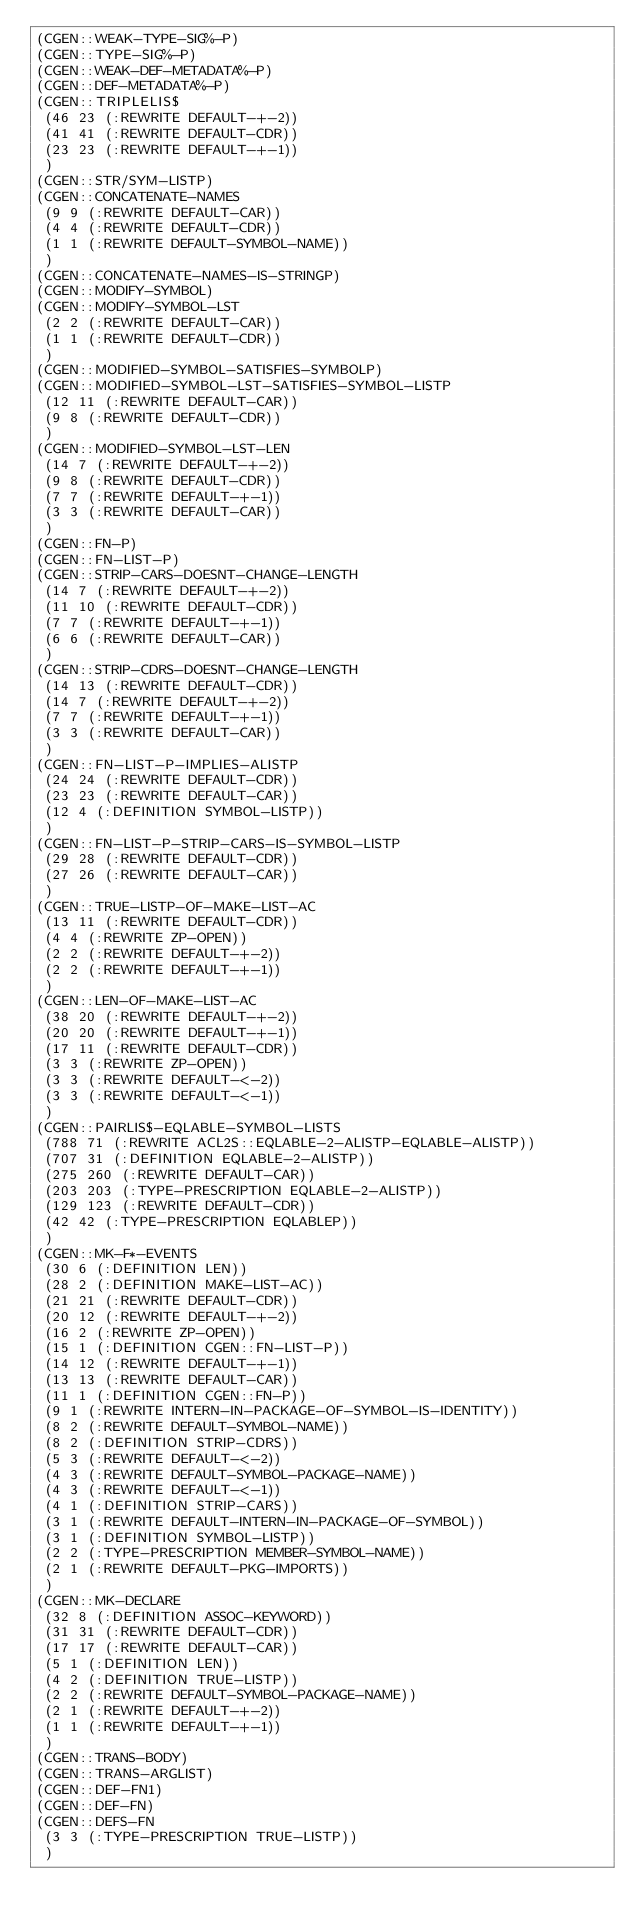Convert code to text. <code><loc_0><loc_0><loc_500><loc_500><_Lisp_>(CGEN::WEAK-TYPE-SIG%-P)
(CGEN::TYPE-SIG%-P)
(CGEN::WEAK-DEF-METADATA%-P)
(CGEN::DEF-METADATA%-P)
(CGEN::TRIPLELIS$
 (46 23 (:REWRITE DEFAULT-+-2))
 (41 41 (:REWRITE DEFAULT-CDR))
 (23 23 (:REWRITE DEFAULT-+-1))
 )
(CGEN::STR/SYM-LISTP)
(CGEN::CONCATENATE-NAMES
 (9 9 (:REWRITE DEFAULT-CAR))
 (4 4 (:REWRITE DEFAULT-CDR))
 (1 1 (:REWRITE DEFAULT-SYMBOL-NAME))
 )
(CGEN::CONCATENATE-NAMES-IS-STRINGP)
(CGEN::MODIFY-SYMBOL)
(CGEN::MODIFY-SYMBOL-LST
 (2 2 (:REWRITE DEFAULT-CAR))
 (1 1 (:REWRITE DEFAULT-CDR))
 )
(CGEN::MODIFIED-SYMBOL-SATISFIES-SYMBOLP)
(CGEN::MODIFIED-SYMBOL-LST-SATISFIES-SYMBOL-LISTP
 (12 11 (:REWRITE DEFAULT-CAR))
 (9 8 (:REWRITE DEFAULT-CDR))
 )
(CGEN::MODIFIED-SYMBOL-LST-LEN
 (14 7 (:REWRITE DEFAULT-+-2))
 (9 8 (:REWRITE DEFAULT-CDR))
 (7 7 (:REWRITE DEFAULT-+-1))
 (3 3 (:REWRITE DEFAULT-CAR))
 )
(CGEN::FN-P)
(CGEN::FN-LIST-P)
(CGEN::STRIP-CARS-DOESNT-CHANGE-LENGTH
 (14 7 (:REWRITE DEFAULT-+-2))
 (11 10 (:REWRITE DEFAULT-CDR))
 (7 7 (:REWRITE DEFAULT-+-1))
 (6 6 (:REWRITE DEFAULT-CAR))
 )
(CGEN::STRIP-CDRS-DOESNT-CHANGE-LENGTH
 (14 13 (:REWRITE DEFAULT-CDR))
 (14 7 (:REWRITE DEFAULT-+-2))
 (7 7 (:REWRITE DEFAULT-+-1))
 (3 3 (:REWRITE DEFAULT-CAR))
 )
(CGEN::FN-LIST-P-IMPLIES-ALISTP
 (24 24 (:REWRITE DEFAULT-CDR))
 (23 23 (:REWRITE DEFAULT-CAR))
 (12 4 (:DEFINITION SYMBOL-LISTP))
 )
(CGEN::FN-LIST-P-STRIP-CARS-IS-SYMBOL-LISTP
 (29 28 (:REWRITE DEFAULT-CDR))
 (27 26 (:REWRITE DEFAULT-CAR))
 )
(CGEN::TRUE-LISTP-OF-MAKE-LIST-AC
 (13 11 (:REWRITE DEFAULT-CDR))
 (4 4 (:REWRITE ZP-OPEN))
 (2 2 (:REWRITE DEFAULT-+-2))
 (2 2 (:REWRITE DEFAULT-+-1))
 )
(CGEN::LEN-OF-MAKE-LIST-AC
 (38 20 (:REWRITE DEFAULT-+-2))
 (20 20 (:REWRITE DEFAULT-+-1))
 (17 11 (:REWRITE DEFAULT-CDR))
 (3 3 (:REWRITE ZP-OPEN))
 (3 3 (:REWRITE DEFAULT-<-2))
 (3 3 (:REWRITE DEFAULT-<-1))
 )
(CGEN::PAIRLIS$-EQLABLE-SYMBOL-LISTS
 (788 71 (:REWRITE ACL2S::EQLABLE-2-ALISTP-EQLABLE-ALISTP))
 (707 31 (:DEFINITION EQLABLE-2-ALISTP))
 (275 260 (:REWRITE DEFAULT-CAR))
 (203 203 (:TYPE-PRESCRIPTION EQLABLE-2-ALISTP))
 (129 123 (:REWRITE DEFAULT-CDR))
 (42 42 (:TYPE-PRESCRIPTION EQLABLEP))
 )
(CGEN::MK-F*-EVENTS
 (30 6 (:DEFINITION LEN))
 (28 2 (:DEFINITION MAKE-LIST-AC))
 (21 21 (:REWRITE DEFAULT-CDR))
 (20 12 (:REWRITE DEFAULT-+-2))
 (16 2 (:REWRITE ZP-OPEN))
 (15 1 (:DEFINITION CGEN::FN-LIST-P))
 (14 12 (:REWRITE DEFAULT-+-1))
 (13 13 (:REWRITE DEFAULT-CAR))
 (11 1 (:DEFINITION CGEN::FN-P))
 (9 1 (:REWRITE INTERN-IN-PACKAGE-OF-SYMBOL-IS-IDENTITY))
 (8 2 (:REWRITE DEFAULT-SYMBOL-NAME))
 (8 2 (:DEFINITION STRIP-CDRS))
 (5 3 (:REWRITE DEFAULT-<-2))
 (4 3 (:REWRITE DEFAULT-SYMBOL-PACKAGE-NAME))
 (4 3 (:REWRITE DEFAULT-<-1))
 (4 1 (:DEFINITION STRIP-CARS))
 (3 1 (:REWRITE DEFAULT-INTERN-IN-PACKAGE-OF-SYMBOL))
 (3 1 (:DEFINITION SYMBOL-LISTP))
 (2 2 (:TYPE-PRESCRIPTION MEMBER-SYMBOL-NAME))
 (2 1 (:REWRITE DEFAULT-PKG-IMPORTS))
 )
(CGEN::MK-DECLARE
 (32 8 (:DEFINITION ASSOC-KEYWORD))
 (31 31 (:REWRITE DEFAULT-CDR))
 (17 17 (:REWRITE DEFAULT-CAR))
 (5 1 (:DEFINITION LEN))
 (4 2 (:DEFINITION TRUE-LISTP))
 (2 2 (:REWRITE DEFAULT-SYMBOL-PACKAGE-NAME))
 (2 1 (:REWRITE DEFAULT-+-2))
 (1 1 (:REWRITE DEFAULT-+-1))
 )
(CGEN::TRANS-BODY)
(CGEN::TRANS-ARGLIST)
(CGEN::DEF-FN1)
(CGEN::DEF-FN)
(CGEN::DEFS-FN
 (3 3 (:TYPE-PRESCRIPTION TRUE-LISTP))
 )
</code> 